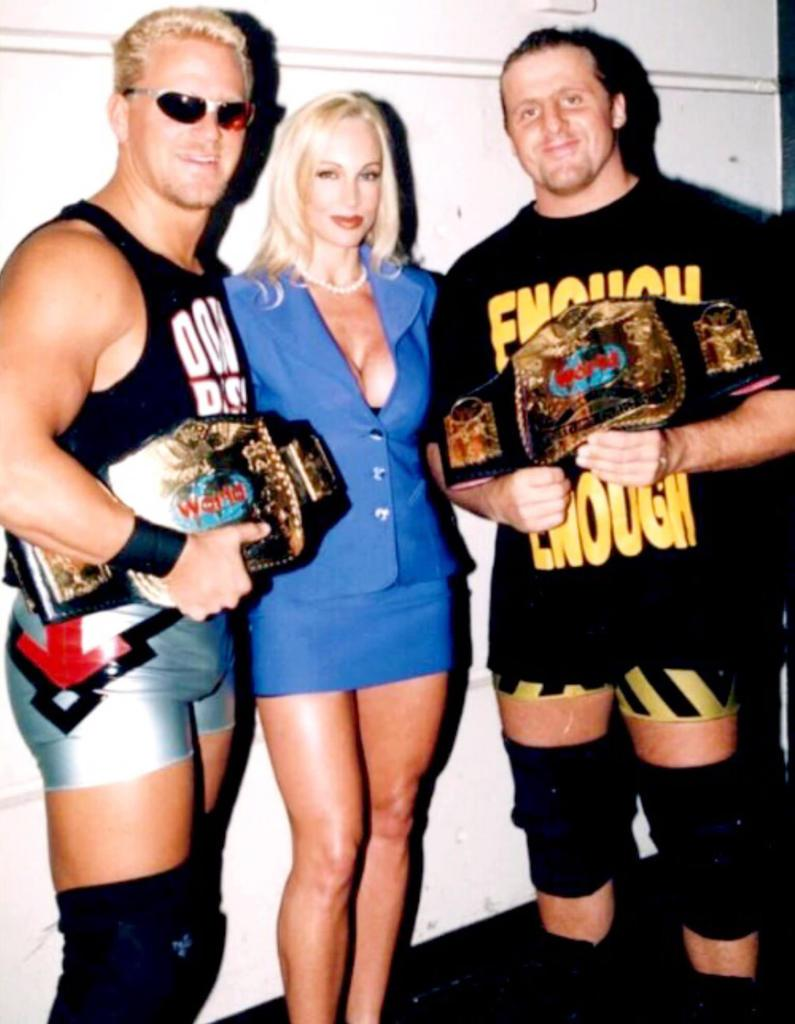<image>
Create a compact narrative representing the image presented. a couple of wrestlers with enough is enough on their outfits 